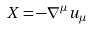Convert formula to latex. <formula><loc_0><loc_0><loc_500><loc_500>X = - { \nabla } ^ { \mu } u _ { \mu }</formula> 